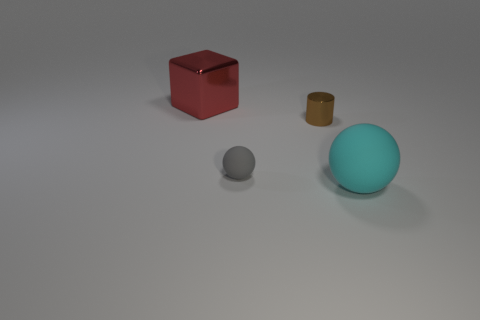What number of other objects are the same size as the red thing?
Keep it short and to the point. 1. There is a object that is in front of the brown cylinder and to the left of the big ball; what material is it?
Provide a short and direct response. Rubber. There is a metal thing that is in front of the red metal object; is its size the same as the cyan rubber object?
Make the answer very short. No. Does the large rubber thing have the same color as the small matte ball?
Your answer should be compact. No. How many things are in front of the metallic cylinder and to the left of the big cyan sphere?
Your answer should be compact. 1. What number of metal cubes are to the left of the shiny thing on the left side of the small thing that is on the left side of the brown metallic thing?
Your answer should be compact. 0. What is the shape of the cyan rubber object?
Your answer should be very brief. Sphere. What number of big things are the same material as the large red block?
Ensure brevity in your answer.  0. There is a big cube that is the same material as the tiny brown cylinder; what color is it?
Provide a succinct answer. Red. There is a red cube; is it the same size as the metallic thing right of the big red block?
Your response must be concise. No. 